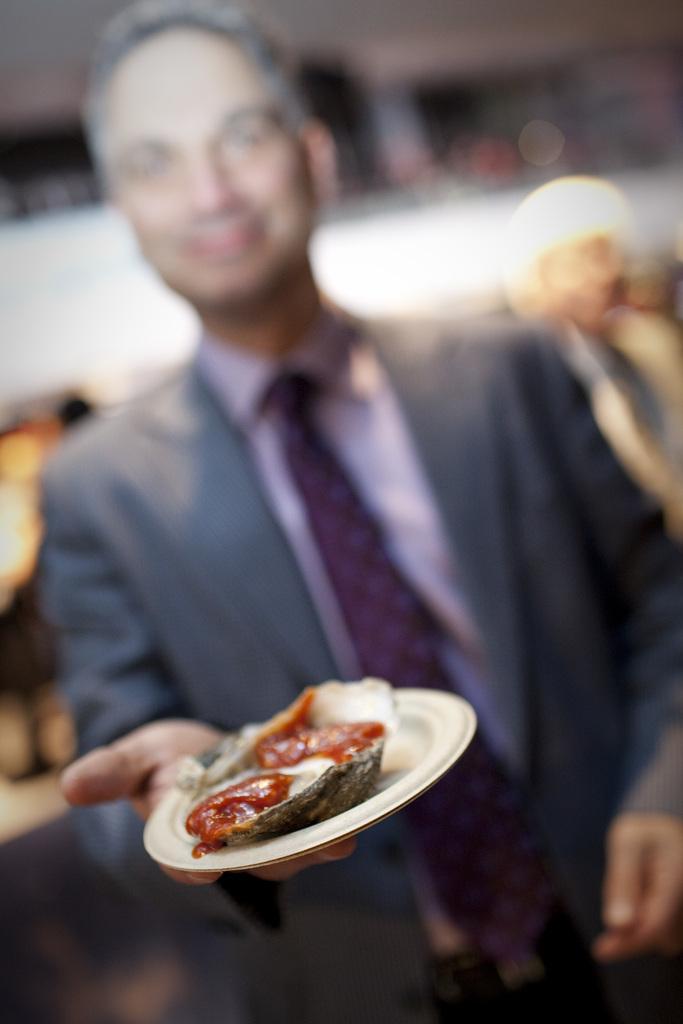How would you summarize this image in a sentence or two? In the image we can see a man wearing clothes and holding a plate in hand, the plate is white in color and on the plate there is a food item. The background is blurred. 